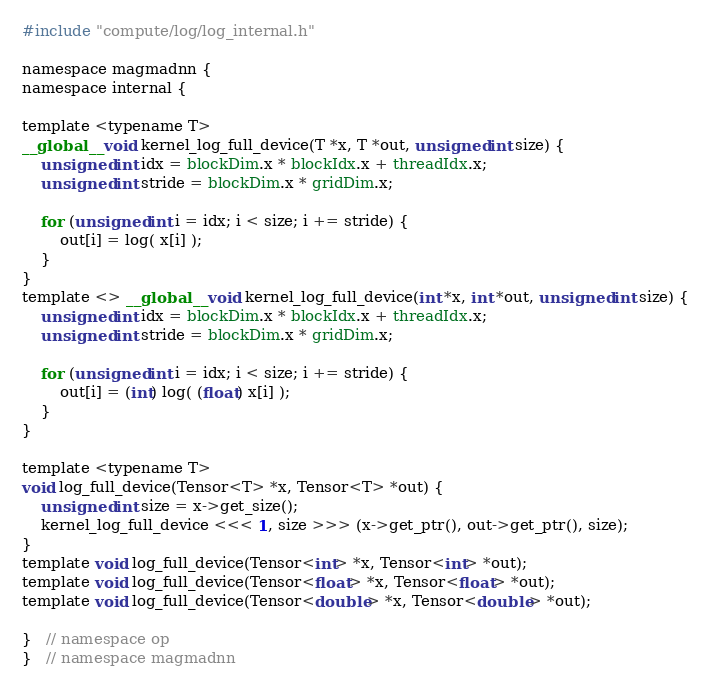<code> <loc_0><loc_0><loc_500><loc_500><_Cuda_>
#include "compute/log/log_internal.h"

namespace magmadnn {
namespace internal {
 
template <typename T>
__global__ void kernel_log_full_device(T *x, T *out, unsigned int size) {
    unsigned int idx = blockDim.x * blockIdx.x + threadIdx.x;
    unsigned int stride = blockDim.x * gridDim.x;

    for (unsigned int i = idx; i < size; i += stride) {
        out[i] = log( x[i] );
    }
}
template <> __global__ void kernel_log_full_device(int *x, int *out, unsigned int size) {
    unsigned int idx = blockDim.x * blockIdx.x + threadIdx.x;
    unsigned int stride = blockDim.x * gridDim.x;

    for (unsigned int i = idx; i < size; i += stride) {
        out[i] = (int) log( (float) x[i] );
    }
}

template <typename T>
void log_full_device(Tensor<T> *x, Tensor<T> *out) {
    unsigned int size = x->get_size();
    kernel_log_full_device <<< 1, size >>> (x->get_ptr(), out->get_ptr(), size);
}
template void log_full_device(Tensor<int> *x, Tensor<int> *out);
template void log_full_device(Tensor<float> *x, Tensor<float> *out);
template void log_full_device(Tensor<double> *x, Tensor<double> *out);
 
}   // namespace op
}   // namespace magmadnn
</code> 